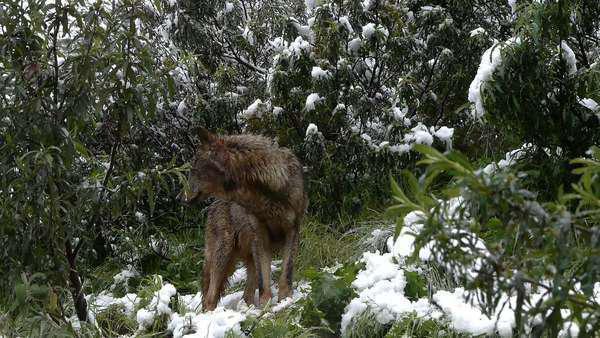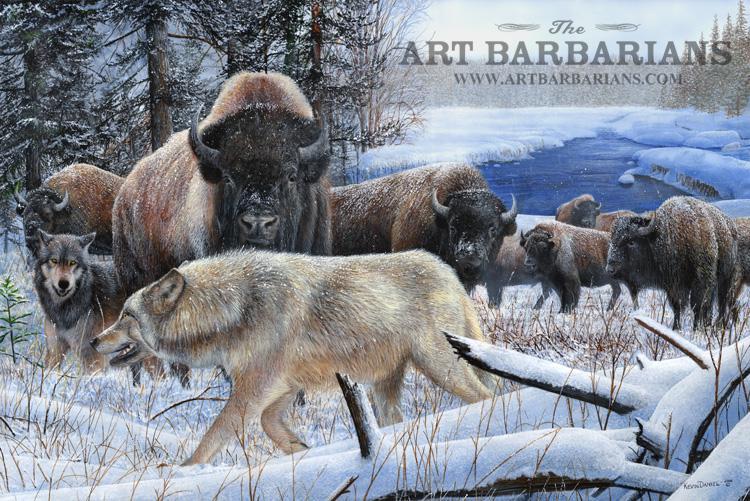The first image is the image on the left, the second image is the image on the right. Examine the images to the left and right. Is the description "A herd of buffalo are behind multiple wolves on snow-covered ground in the right image." accurate? Answer yes or no. Yes. 